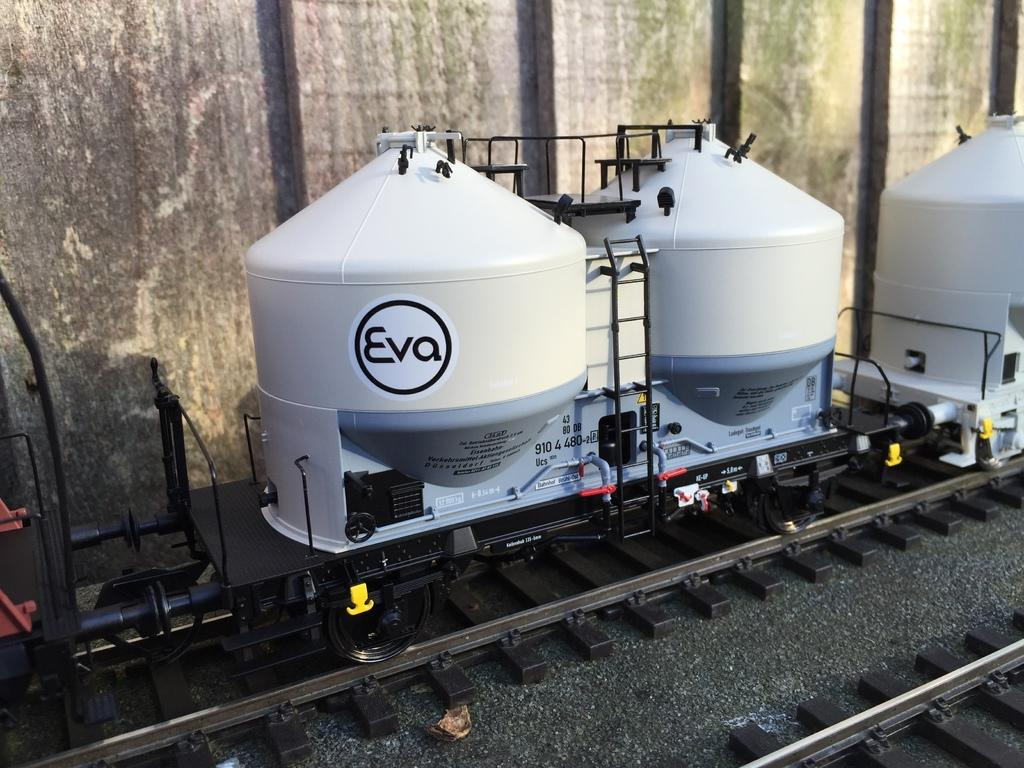What objects are placed on the surface in the image? There are toys placed on a surface in the image. What can be seen at the top of the image? There is a wall visible at the top of the image. Where is the goat located in the image? There is no goat present in the image. What type of material is the alley made of in the image? There is no alley present in the image. 